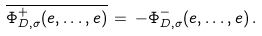Convert formula to latex. <formula><loc_0><loc_0><loc_500><loc_500>\overline { \Phi ^ { + } _ { D , \sigma } ( e , \dots , e ) } \, = \, - \Phi ^ { - } _ { D , \sigma } ( e , \dots , e ) \, .</formula> 